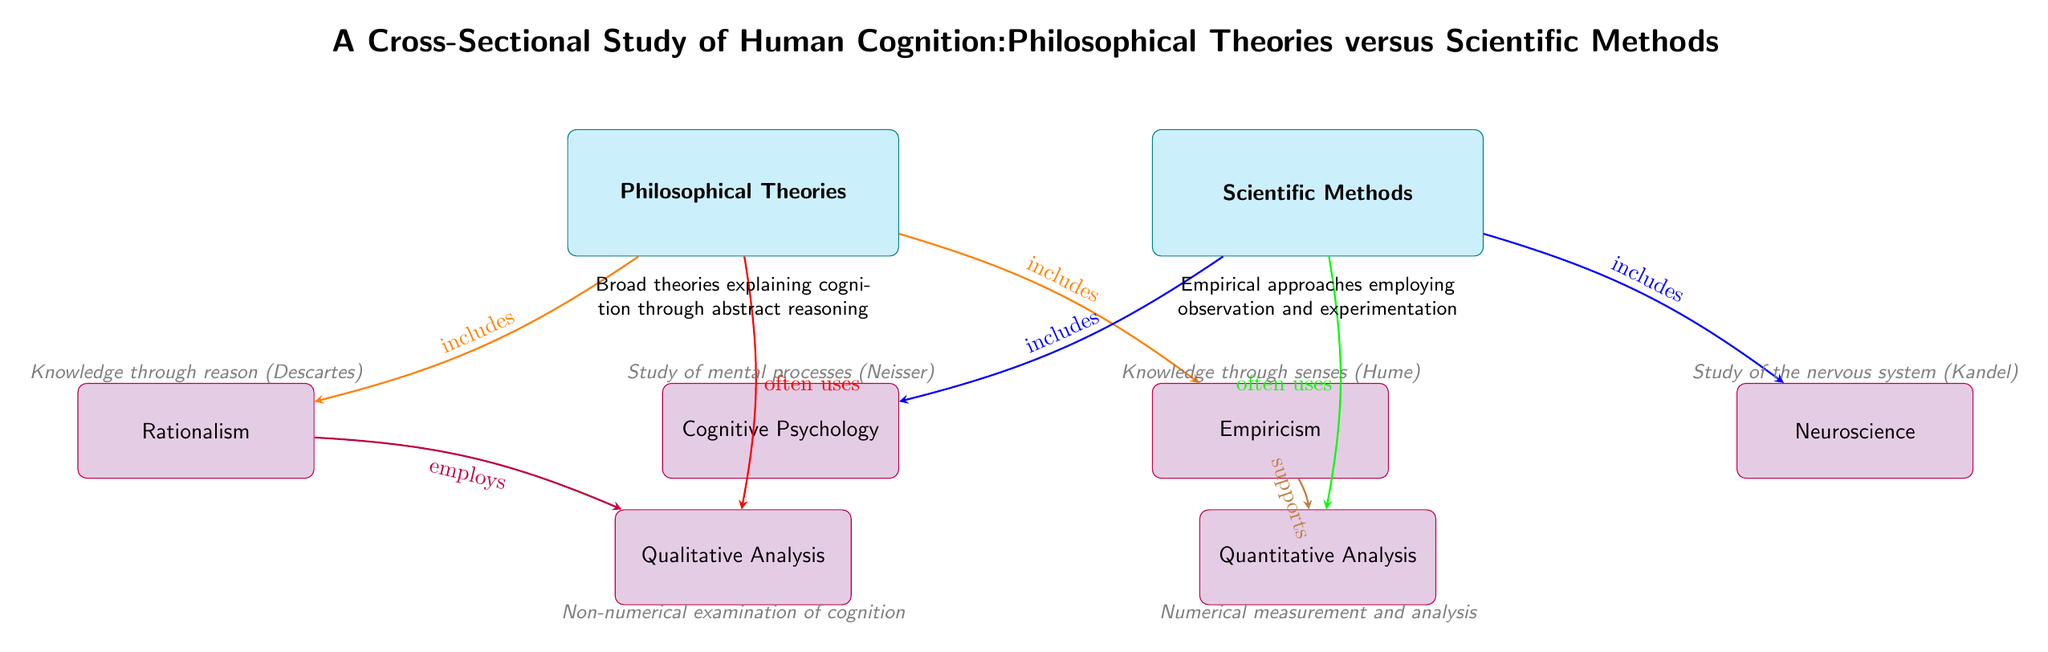What are the two main categories presented in the diagram? The diagram contains two main categories: "Philosophical Theories" and "Scientific Methods," which are the highest-level nodes depicted at the top of the diagram.
Answer: Philosophical Theories, Scientific Methods How many sub-nodes are linked to "Philosophical Theories"? There are two sub-nodes linked to "Philosophical Theories," which are "Rationalism" and "Empiricism," indicated by the two arrows pointing down from this main node.
Answer: 2 What type of analysis is often used by "Philosophical Theories"? The diagram indicates that "Philosophical Theories" often uses "Qualitative Analysis," as shown by the arrow pointing from the main node to this analysis method.
Answer: Qualitative Analysis Which philosophical theory supports "Quantitative Analysis"? The diagram shows that "Empiricism" supports "Quantitative Analysis," with a direct arrow connecting the two.
Answer: Empiricism What is the relationship between “Rationalism” and “Qualitative Analysis”? "Rationalism" employs "Qualitative Analysis," as indicated by the arrow that connects these two nodes with the label "employs."
Answer: employs Describe the connection between "Scientific Methods" and the field of "Cognitive Psychology". "Cognitive Psychology" is included in "Scientific Methods," as shown by the arrow that points from "Scientific Methods" to "Cognitive Psychology," with the label "includes."
Answer: includes What are the two approaches specified under "Scientific Methods"? The diagram specifies "Cognitive Psychology" and "Neuroscience" as the two approaches under "Scientific Methods," both connected with arrows indicating inclusion.
Answer: Cognitive Psychology, Neuroscience Which main node does "Neuroscience" connect to and what type of method does it represent? "Neuroscience" connects to "Scientific Methods," representing an empirical method that relies on scientific observation, as described in the node texts in the diagram.
Answer: Scientific Methods 